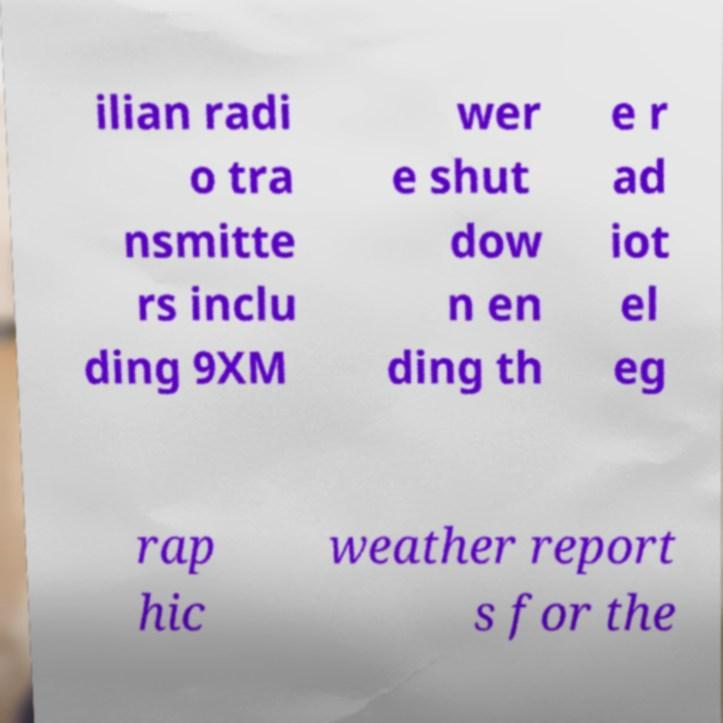What messages or text are displayed in this image? I need them in a readable, typed format. ilian radi o tra nsmitte rs inclu ding 9XM wer e shut dow n en ding th e r ad iot el eg rap hic weather report s for the 